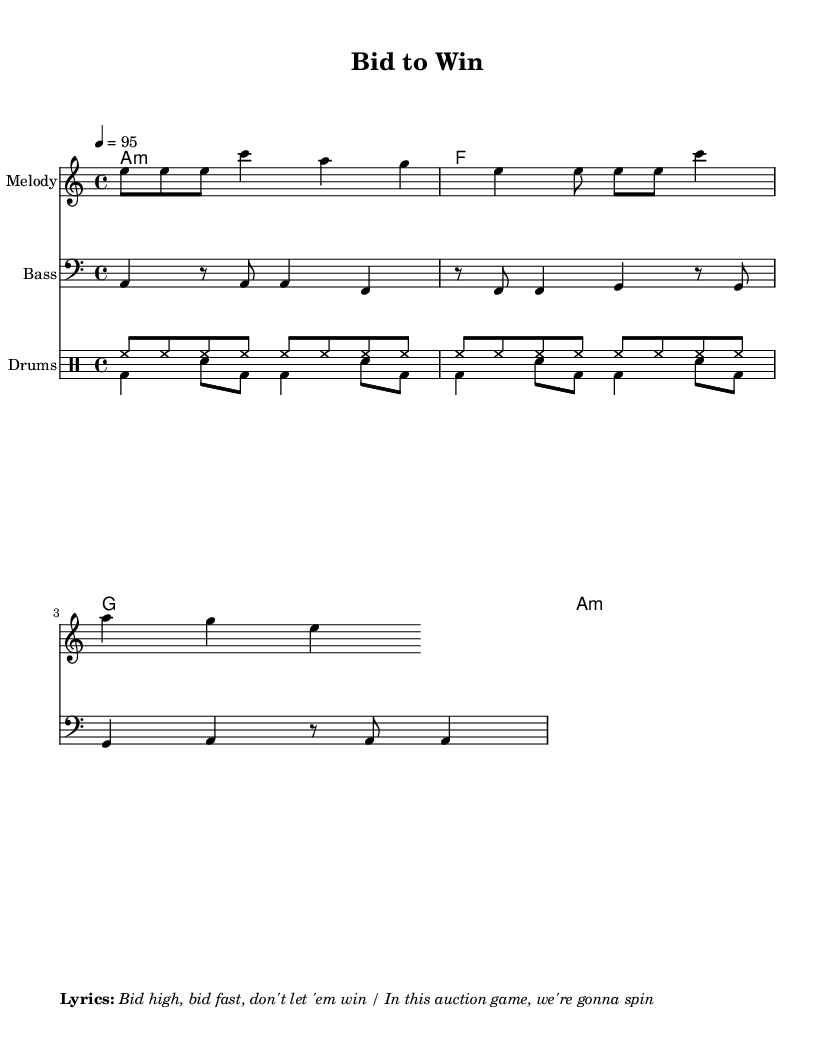What is the title of this sheet music? The title is found in the header section of the code, where it is explicitly mentioned as "Bid to Win".
Answer: Bid to Win What is the key signature of this music? The music is in a-minor, which indicates it contains one sharp (the note G#). This can be deduced from the 'global' section where it states \key a \minor.
Answer: A minor What is the time signature? The time signature is noted as 4/4 in the 'global' section of the code. This means there are four beats in each measure.
Answer: 4/4 What is the tempo marking for this piece? The tempo marking is determined from the 'global' section, which shows the tempo set to 95 beats per minute.
Answer: 95 How many distinct drum patterns are included? Upon examining the drum sections, there are two patterns specified: one for the hi-hat (upbeat pattern) and one for the bass drum/snare (downbeat pattern). Therefore, it indicates two distinct patterns.
Answer: Two What genre does this music represent? The style is indicated by the context of the title and the upbeat nature of the rhythms, which are characteristic of reggaeton music, especially with elements focusing on high-stakes bidding.
Answer: Reggaeton What do the lyrics suggest about the theme? The lyrics emphasize the urgency of bidding fast and winning, indicative of the competitive atmosphere of auctions. This connects to the up-tempo style prevalent in reggaeton music.
Answer: Competitive bidding 